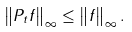Convert formula to latex. <formula><loc_0><loc_0><loc_500><loc_500>\left \| P _ { t } f \right \| _ { \infty } \leq \left \| f \right \| _ { \infty } .</formula> 